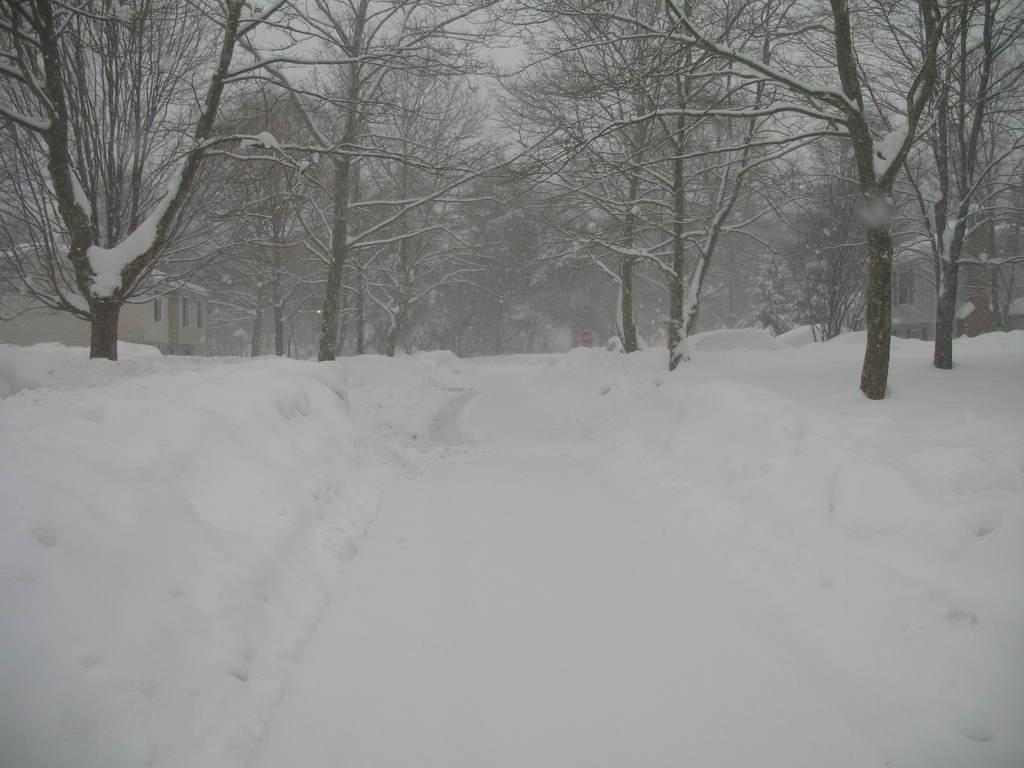What is covering the ground in the image? There is snow on the ground in the image. What can be seen in the distance behind the snow-covered ground? There are trees and buildings in the background of the image. What type of stew is being prepared in the image? There is no stew present in the image; it features snow on the ground and trees and buildings in the background. 